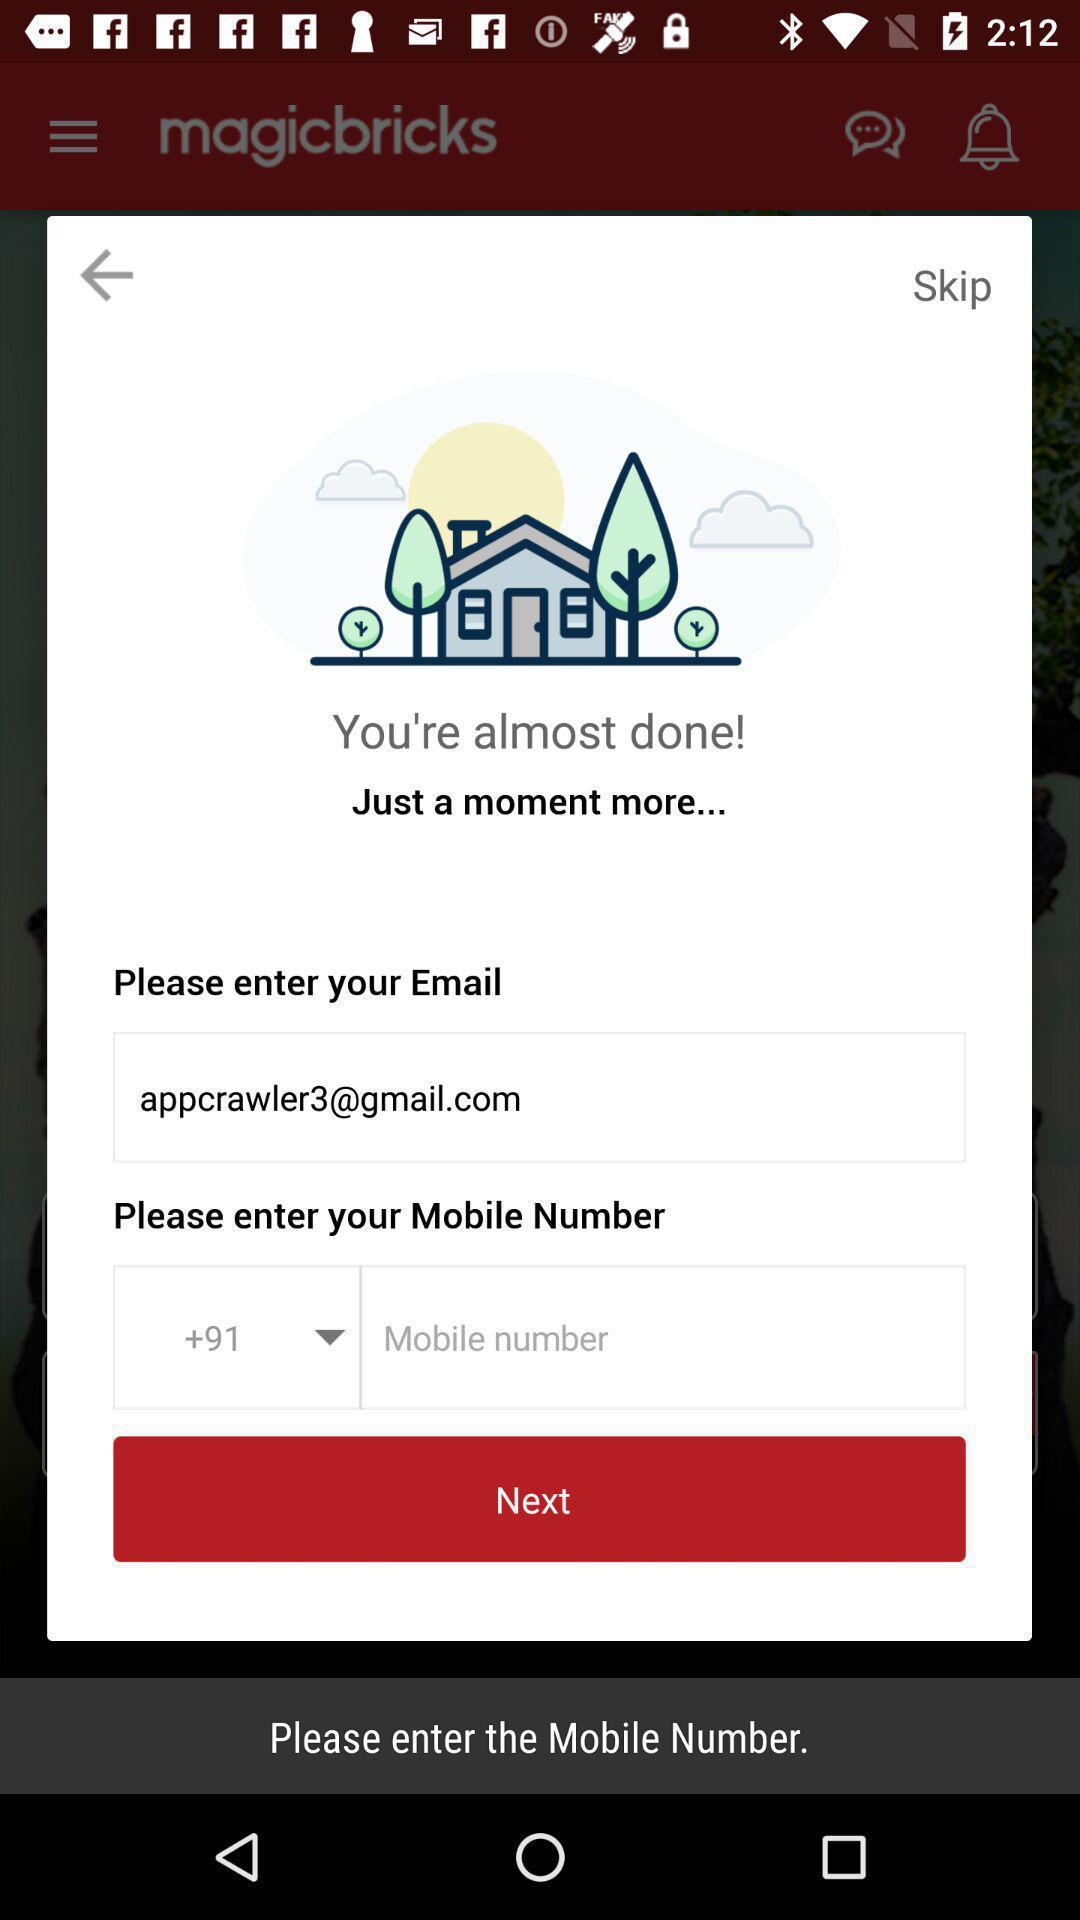What is the email address? The email address is appcrawler3@gmail.com. 